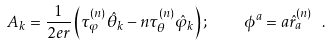Convert formula to latex. <formula><loc_0><loc_0><loc_500><loc_500>A _ { k } = \frac { 1 } { 2 e r } \left ( \tau _ { \varphi } ^ { ( n ) } { \hat { \theta } } _ { k } - n \tau _ { \theta } ^ { ( n ) } { \hat { \varphi } } _ { k } \right ) ; \quad \phi ^ { a } = a { \hat { r } } _ { a } ^ { ( n ) } \ .</formula> 